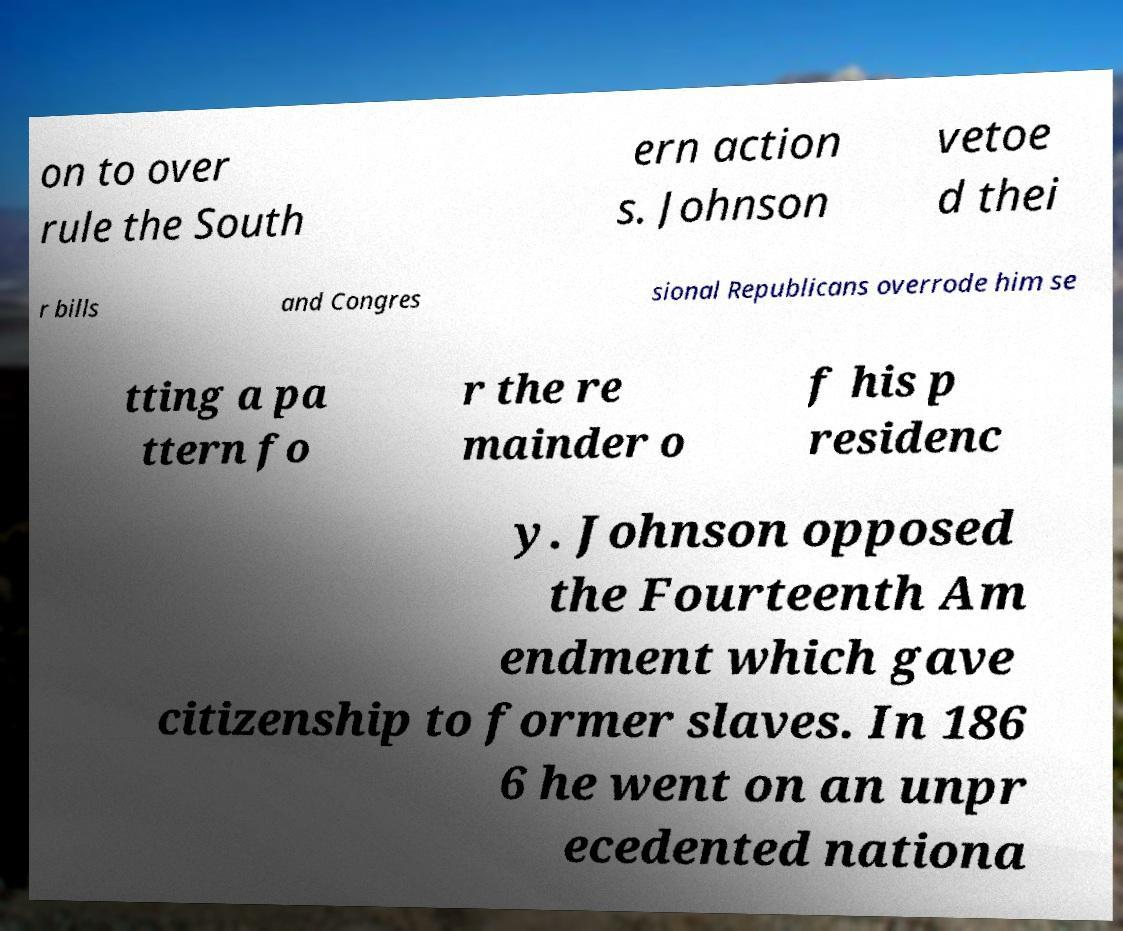Please identify and transcribe the text found in this image. on to over rule the South ern action s. Johnson vetoe d thei r bills and Congres sional Republicans overrode him se tting a pa ttern fo r the re mainder o f his p residenc y. Johnson opposed the Fourteenth Am endment which gave citizenship to former slaves. In 186 6 he went on an unpr ecedented nationa 